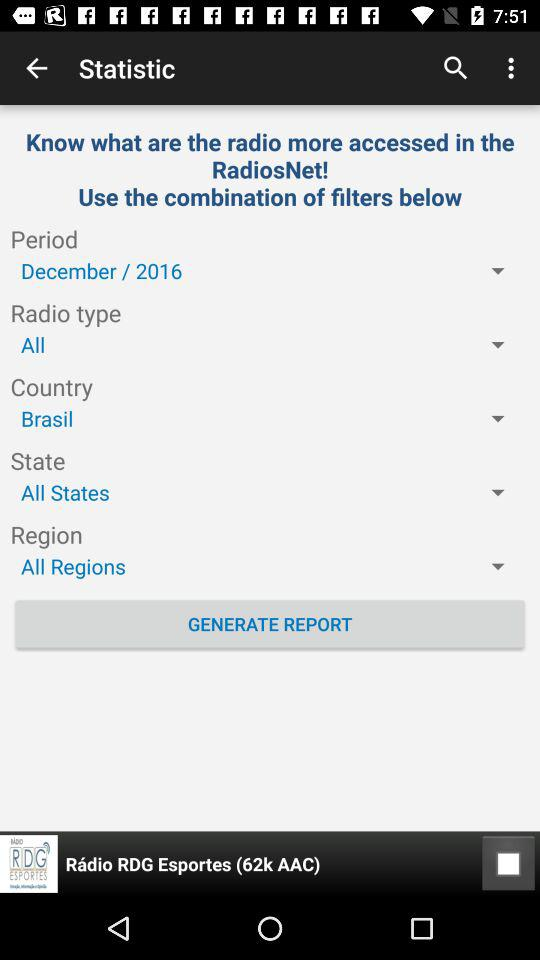Which option is selected in "State"? The selected option is "All States". 